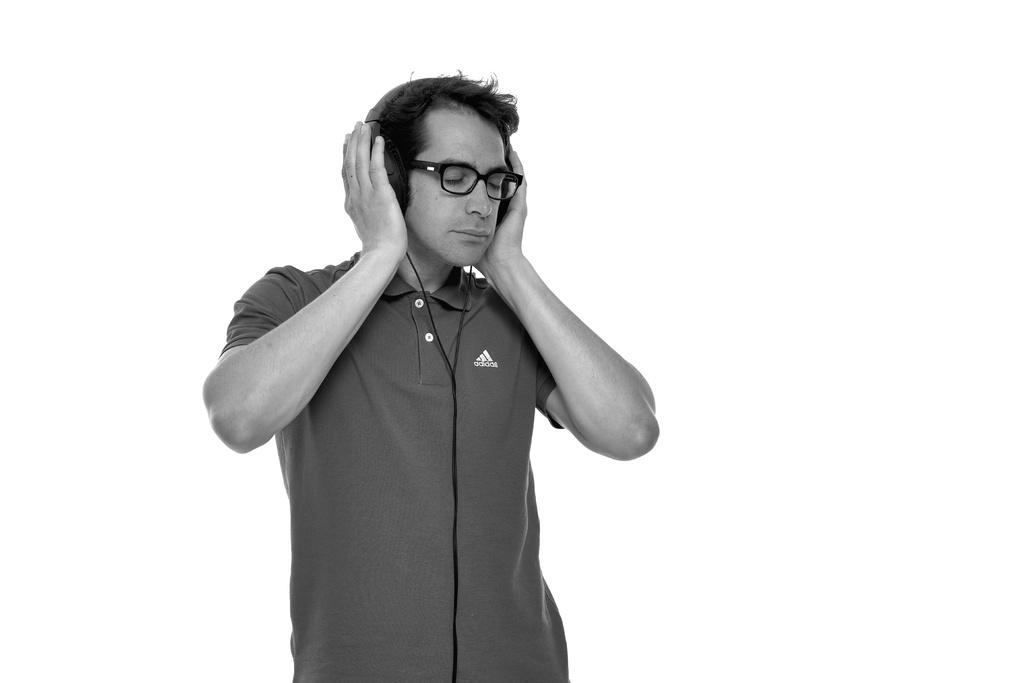What is the main subject of the image? There is a person standing in the image. What is the person holding in the image? The person is holding headphones. What is the color of the background in the image? The background in the image is white. What type of brass instrument can be seen in the image? There is no brass instrument present in the image; it features a person holding headphones against a white background. 